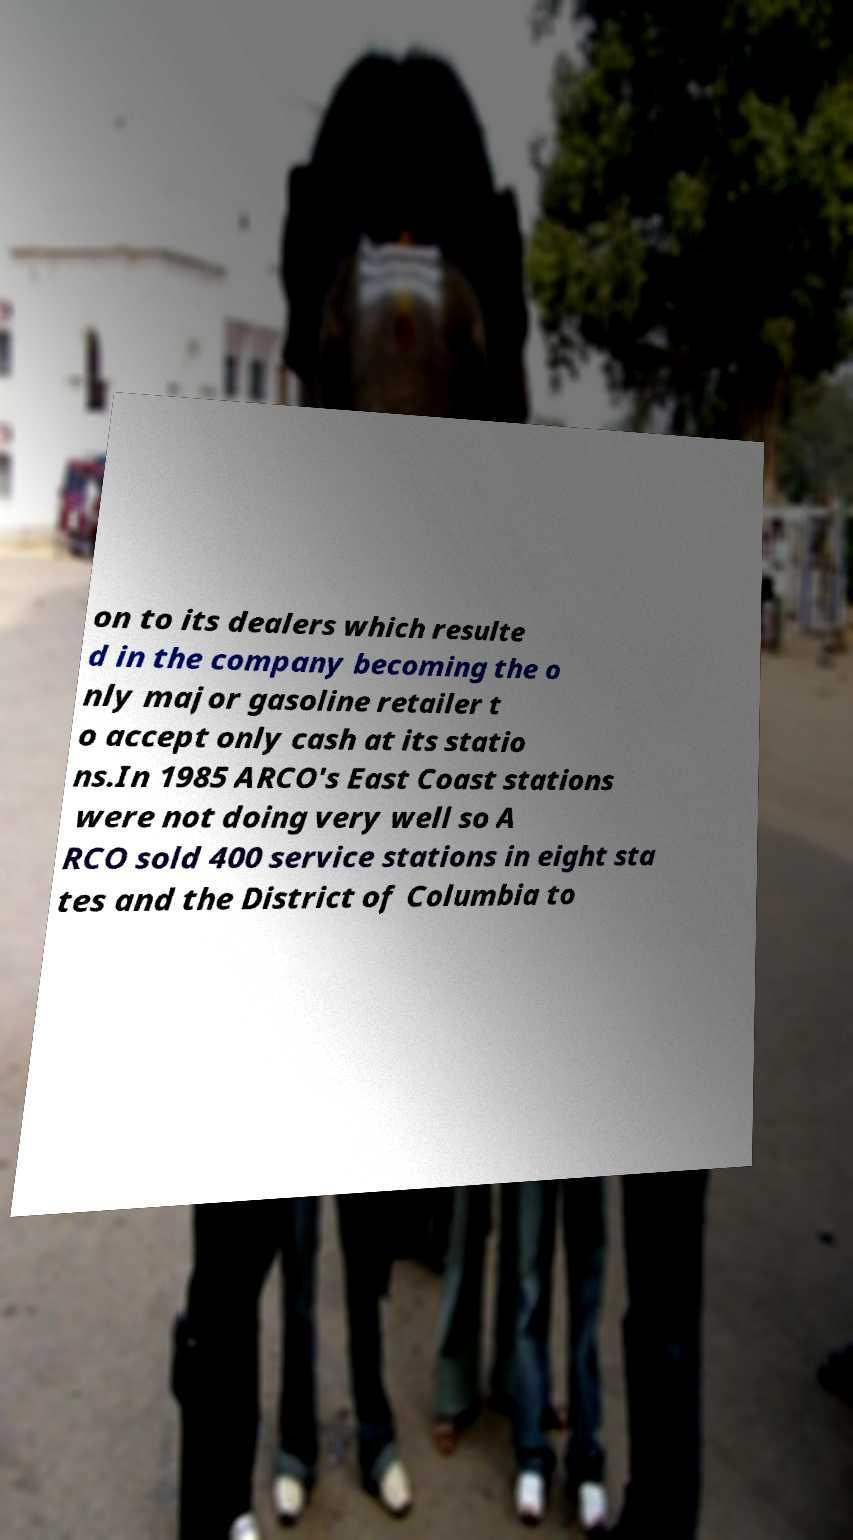Could you extract and type out the text from this image? on to its dealers which resulte d in the company becoming the o nly major gasoline retailer t o accept only cash at its statio ns.In 1985 ARCO's East Coast stations were not doing very well so A RCO sold 400 service stations in eight sta tes and the District of Columbia to 